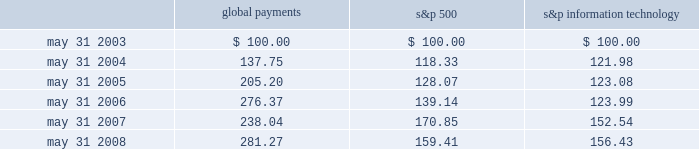Stock performance graph the following line-graph presentation compares our cumulative shareholder returns with the standard & poor 2019s information technology index and the standard & poor 2019s 500 stock index for the past five years .
The line graph assumes the investment of $ 100 in our common stock , the standard & poor 2019s information technology index , and the standard & poor 2019s 500 stock index on may 31 , 2003 and assumes reinvestment of all dividends .
Comparison of 5 year cumulative total return* among global payments inc. , the s&p 500 index and the s&p information technology index 5/03 5/04 5/05 5/06 5/07 5/08 global payments inc .
S&p 500 s&p information technology * $ 100 invested on 5/31/03 in stock or index-including reinvestment of dividends .
Fiscal year ending may 31 .
Global payments s&p 500 information technology .
Issuer purchases of equity securities in fiscal 2007 , our board of directors approved a share repurchase program that authorized the purchase of up to $ 100 million of global payments 2019 stock in the open market or as otherwise may be determined by us , subject to market conditions , business opportunities , and other factors .
Under this authorization , we have repurchased 2.3 million shares of our common stock .
This authorization has no expiration date and may be suspended or terminated at any time .
Repurchased shares will be retired but will be available for future issuance. .
In a slight recession of the overall market , what percentage did the stock price of global payments change? 
Rationale: the s&p 500 is a good indicator of the overall market , therefore when that drops that means there was a slight recession that year . however , global payments did not follow the trend and rose 18.6% . this was calculated by taking the final price and subtracting it by the initial price . then take the answer and dividing by the initial price .
Computations: (281.27 - 238.04)
Answer: 43.23. 